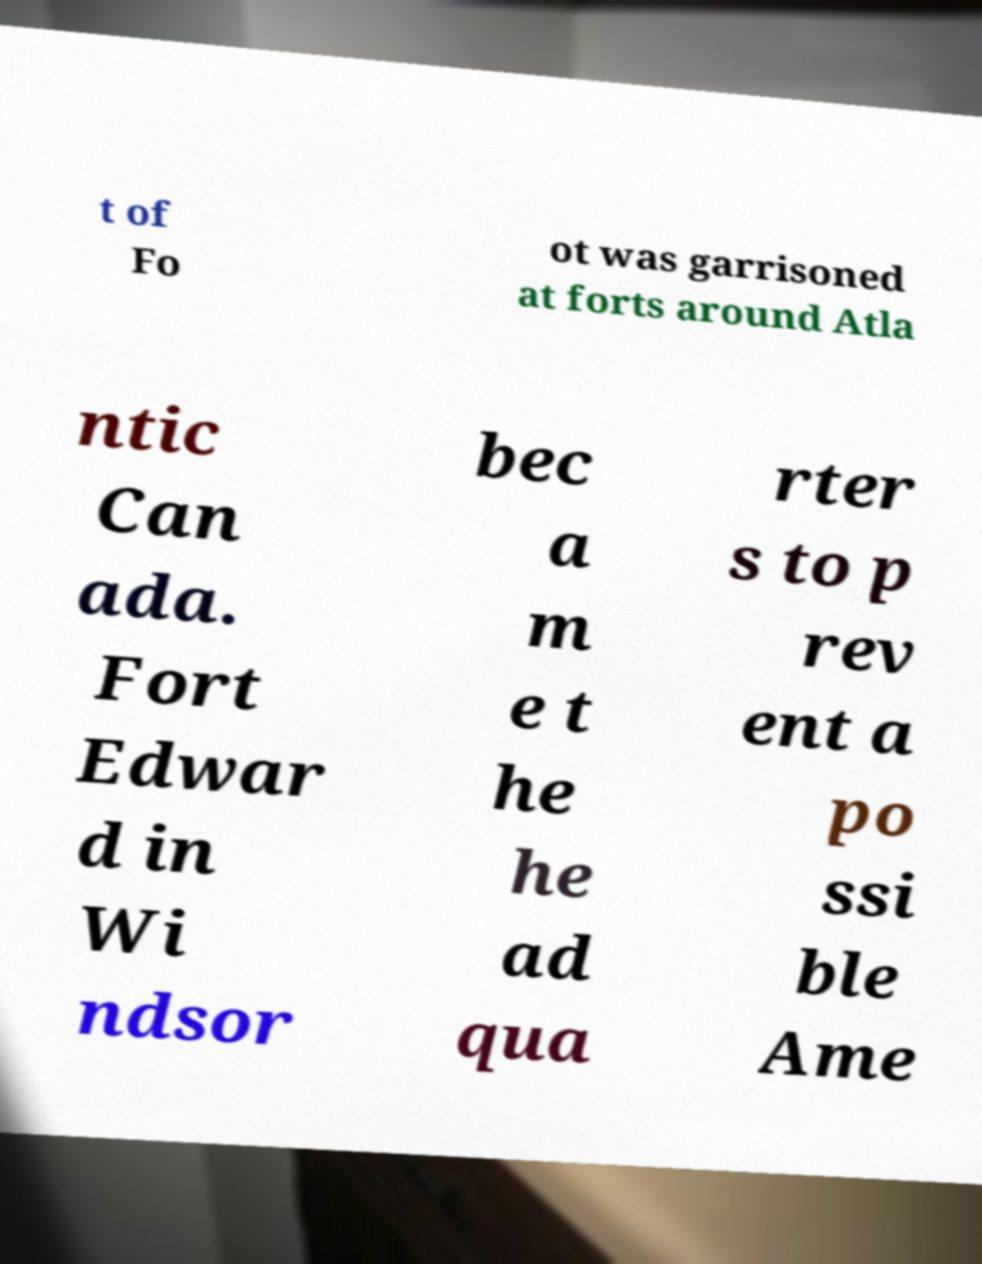Can you accurately transcribe the text from the provided image for me? t of Fo ot was garrisoned at forts around Atla ntic Can ada. Fort Edwar d in Wi ndsor bec a m e t he he ad qua rter s to p rev ent a po ssi ble Ame 